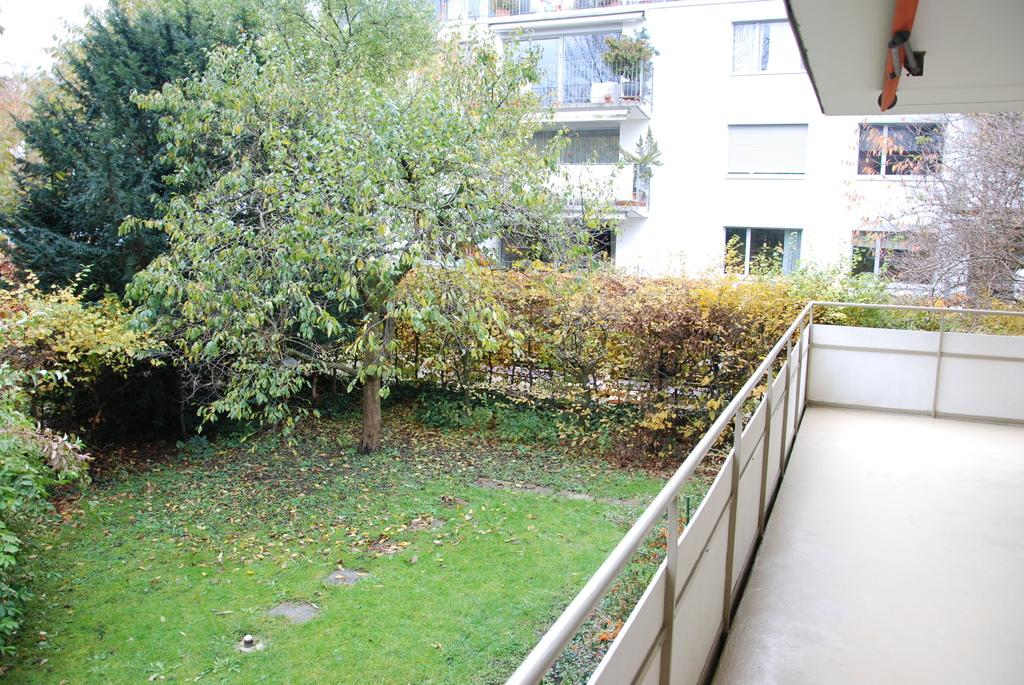What type of structures can be seen in the image? There are buildings in the image. What is located in front of the buildings? There are trees, plants, a fence, and grass in front of the buildings. Can you describe the object attached to the roof of one of the buildings? Unfortunately, the image does not provide enough detail to describe the object attached to the roof of one of the buildings. What type of sock is hanging on the fence in the image? There is no sock present in the image; it only features buildings, trees, plants, a fence, grass, and an object on the roof of one of the buildings. 